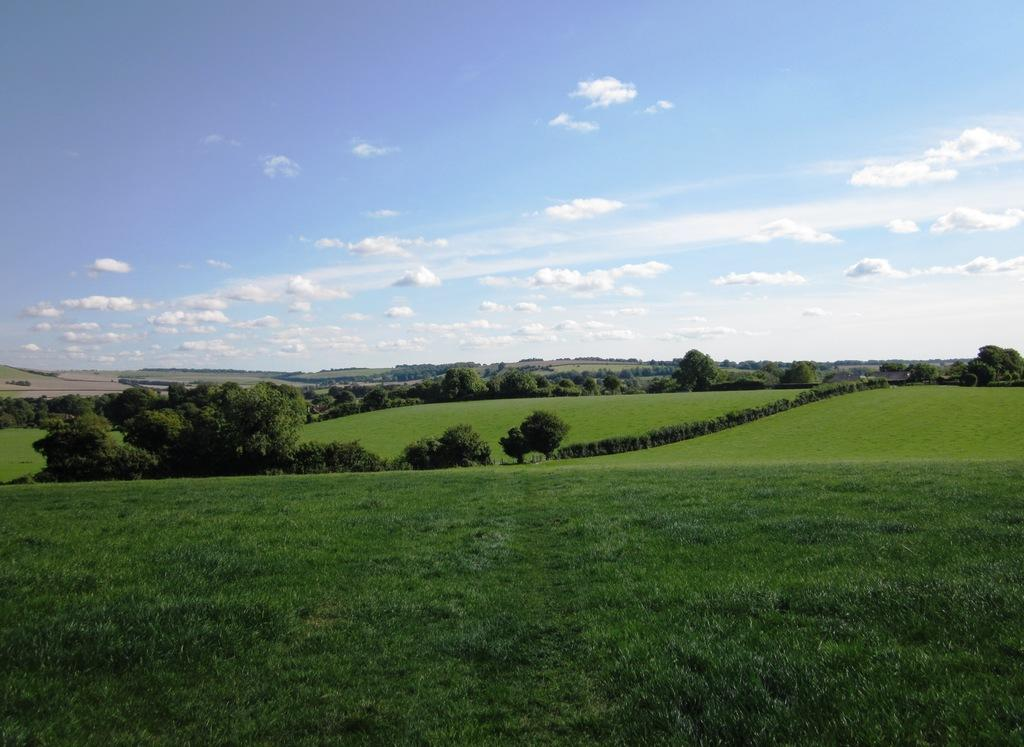What type of vegetation is present on the ground in the image? There is grass on the ground in the image. What other natural elements can be seen in the image? There are trees in the image. What is visible in the background of the image? The sky is visible in the background of the image. What type of pancake is being used to cover the trees in the image? There is no pancake present in the image, and the trees are not being covered by anything. 